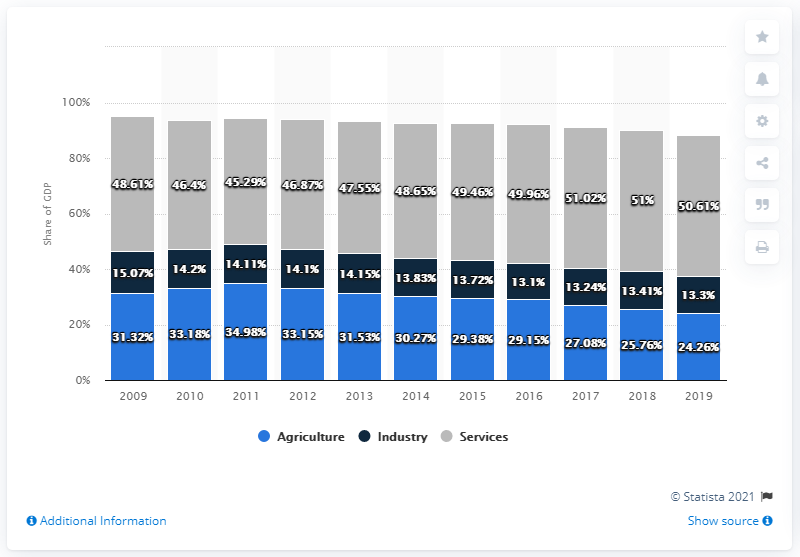Mention a couple of crucial points in this snapshot. The services sector has been the economic sector that has grown in the distribution of GDP in Nepal since 2009. In 2019, the Agriculture and Industry sector collectively contributed the lowest amount to Nepal's Gross Domestic Product (GDP). 